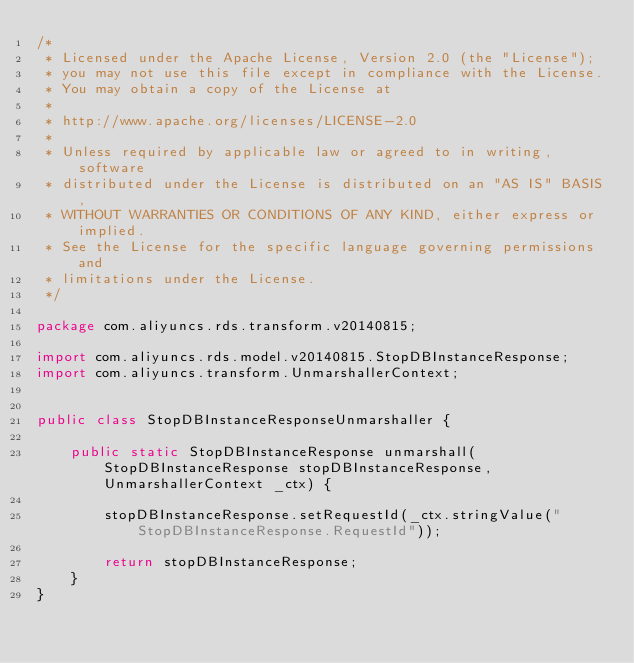Convert code to text. <code><loc_0><loc_0><loc_500><loc_500><_Java_>/*
 * Licensed under the Apache License, Version 2.0 (the "License");
 * you may not use this file except in compliance with the License.
 * You may obtain a copy of the License at
 *
 * http://www.apache.org/licenses/LICENSE-2.0
 *
 * Unless required by applicable law or agreed to in writing, software
 * distributed under the License is distributed on an "AS IS" BASIS,
 * WITHOUT WARRANTIES OR CONDITIONS OF ANY KIND, either express or implied.
 * See the License for the specific language governing permissions and
 * limitations under the License.
 */

package com.aliyuncs.rds.transform.v20140815;

import com.aliyuncs.rds.model.v20140815.StopDBInstanceResponse;
import com.aliyuncs.transform.UnmarshallerContext;


public class StopDBInstanceResponseUnmarshaller {

	public static StopDBInstanceResponse unmarshall(StopDBInstanceResponse stopDBInstanceResponse, UnmarshallerContext _ctx) {
		
		stopDBInstanceResponse.setRequestId(_ctx.stringValue("StopDBInstanceResponse.RequestId"));
	 
	 	return stopDBInstanceResponse;
	}
}</code> 